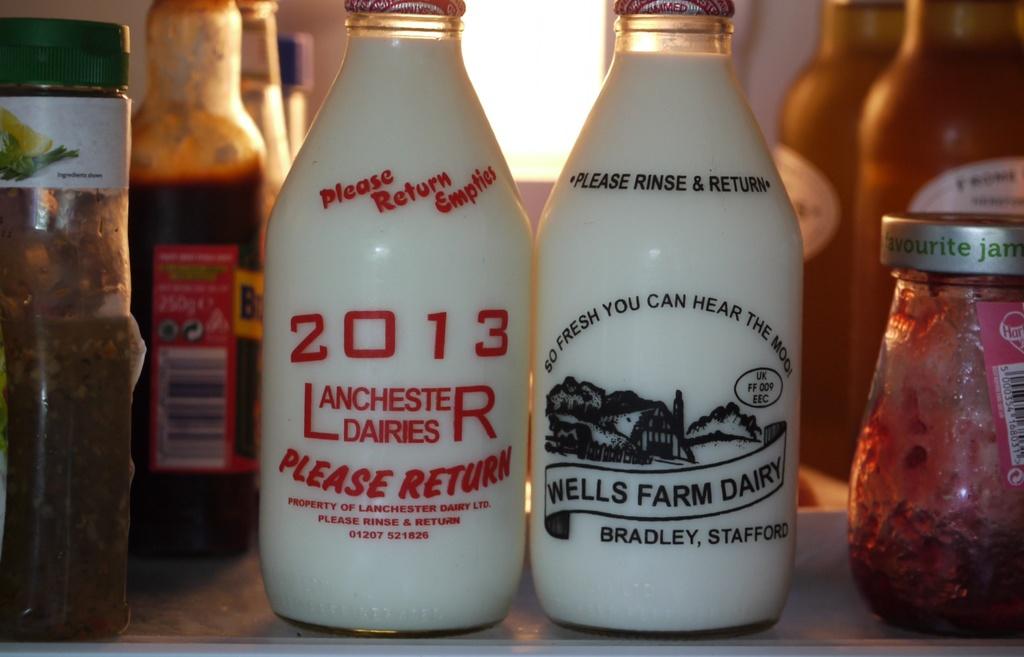What dairy is the left bottle from?
Your response must be concise. Lanchester. 